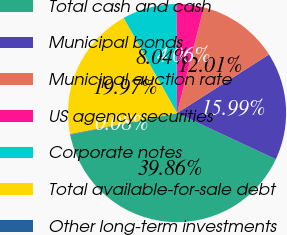<chart> <loc_0><loc_0><loc_500><loc_500><pie_chart><fcel>Total cash and cash<fcel>Municipal bonds<fcel>Municipal auction rate<fcel>US agency securities<fcel>Corporate notes<fcel>Total available-for-sale debt<fcel>Other long-term investments<nl><fcel>39.86%<fcel>15.99%<fcel>12.01%<fcel>4.06%<fcel>8.04%<fcel>19.97%<fcel>0.08%<nl></chart> 